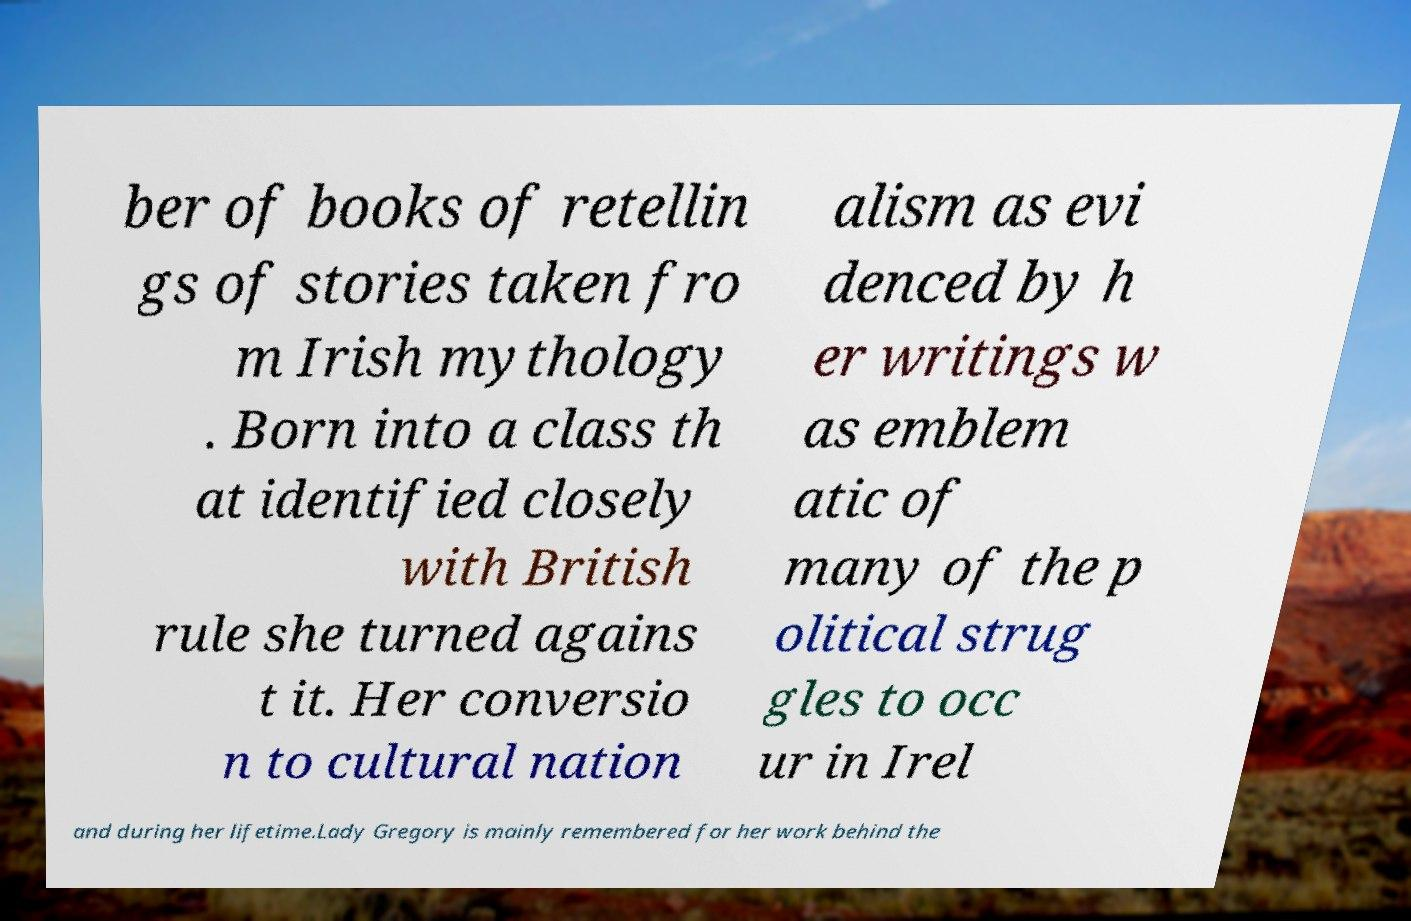Could you assist in decoding the text presented in this image and type it out clearly? ber of books of retellin gs of stories taken fro m Irish mythology . Born into a class th at identified closely with British rule she turned agains t it. Her conversio n to cultural nation alism as evi denced by h er writings w as emblem atic of many of the p olitical strug gles to occ ur in Irel and during her lifetime.Lady Gregory is mainly remembered for her work behind the 